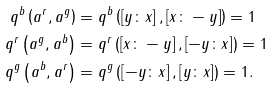Convert formula to latex. <formula><loc_0><loc_0><loc_500><loc_500>q ^ { b } \left ( a ^ { r } , a ^ { g } \right ) & = q ^ { b } \left ( \left [ y \colon x \right ] , \left [ x \colon - y \right ] \right ) = 1 \\ q ^ { r } \left ( a ^ { g } , a ^ { b } \right ) & = q ^ { r } \left ( \left [ x \colon - y \right ] , \left [ - y \colon x \right ] \right ) = 1 \\ q ^ { g } \left ( a ^ { b } , a ^ { r } \right ) & = q ^ { g } \left ( \left [ - y \colon x \right ] , \left [ y \colon x \right ] \right ) = 1 .</formula> 